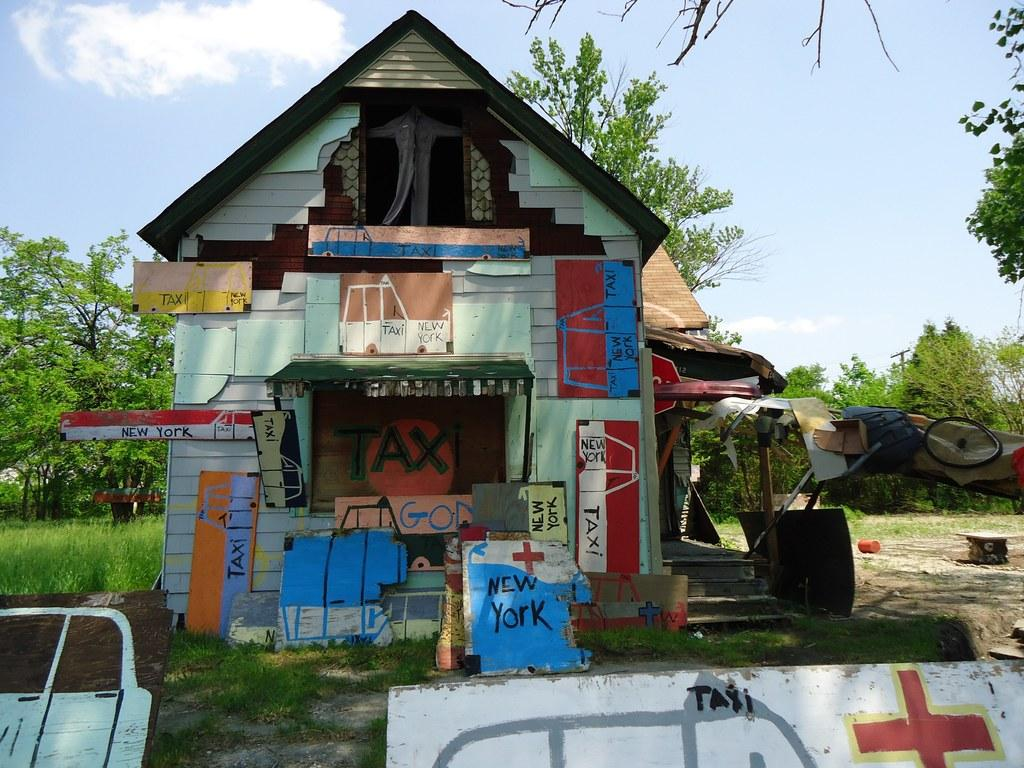What structure is located in the center of the image? There is a shed in the center of the image. What material can be seen in the image? There are boards visible in the image. What can be seen in the background of the image? There is a tent, trees, a pole, and the sky visible in the background of the image. What type of collar can be seen on the trees in the image? There is no collar present on the trees in the image; it only features a shed, boards, a tent, trees, a pole, and the sky. 